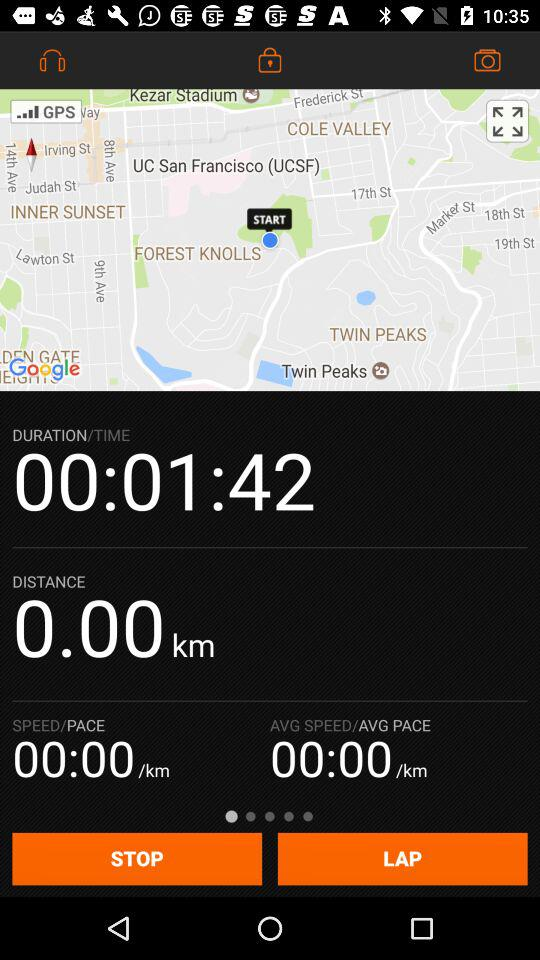What is the duration? The duration is 1 minute and 42 seconds. 